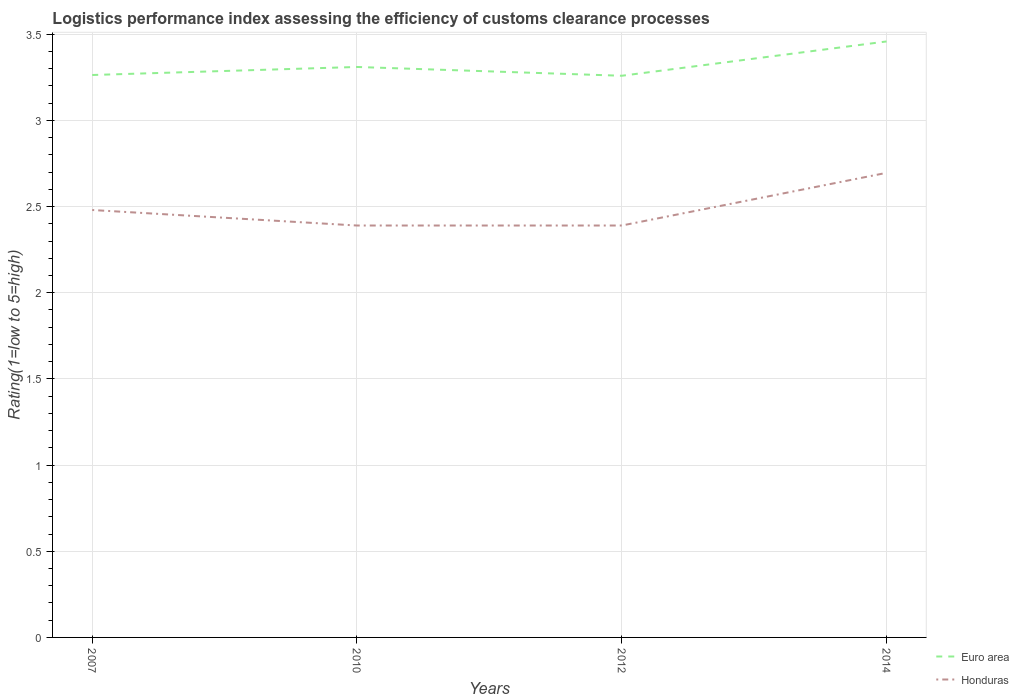Does the line corresponding to Euro area intersect with the line corresponding to Honduras?
Offer a terse response. No. Across all years, what is the maximum Logistic performance index in Honduras?
Make the answer very short. 2.39. In which year was the Logistic performance index in Honduras maximum?
Provide a succinct answer. 2010. What is the total Logistic performance index in Honduras in the graph?
Offer a very short reply. -0.31. What is the difference between the highest and the second highest Logistic performance index in Honduras?
Your response must be concise. 0.31. What is the difference between the highest and the lowest Logistic performance index in Honduras?
Offer a very short reply. 1. Is the Logistic performance index in Euro area strictly greater than the Logistic performance index in Honduras over the years?
Provide a succinct answer. No. How many lines are there?
Ensure brevity in your answer.  2. Does the graph contain any zero values?
Offer a terse response. No. How many legend labels are there?
Make the answer very short. 2. How are the legend labels stacked?
Your response must be concise. Vertical. What is the title of the graph?
Ensure brevity in your answer.  Logistics performance index assessing the efficiency of customs clearance processes. Does "Bahrain" appear as one of the legend labels in the graph?
Provide a succinct answer. No. What is the label or title of the Y-axis?
Offer a very short reply. Rating(1=low to 5=high). What is the Rating(1=low to 5=high) of Euro area in 2007?
Your answer should be compact. 3.26. What is the Rating(1=low to 5=high) in Honduras in 2007?
Your answer should be very brief. 2.48. What is the Rating(1=low to 5=high) of Euro area in 2010?
Offer a terse response. 3.31. What is the Rating(1=low to 5=high) in Honduras in 2010?
Ensure brevity in your answer.  2.39. What is the Rating(1=low to 5=high) in Euro area in 2012?
Provide a succinct answer. 3.26. What is the Rating(1=low to 5=high) of Honduras in 2012?
Offer a very short reply. 2.39. What is the Rating(1=low to 5=high) in Euro area in 2014?
Your answer should be compact. 3.46. What is the Rating(1=low to 5=high) in Honduras in 2014?
Your answer should be very brief. 2.7. Across all years, what is the maximum Rating(1=low to 5=high) of Euro area?
Provide a short and direct response. 3.46. Across all years, what is the maximum Rating(1=low to 5=high) in Honduras?
Make the answer very short. 2.7. Across all years, what is the minimum Rating(1=low to 5=high) in Euro area?
Provide a short and direct response. 3.26. Across all years, what is the minimum Rating(1=low to 5=high) of Honduras?
Keep it short and to the point. 2.39. What is the total Rating(1=low to 5=high) of Euro area in the graph?
Offer a terse response. 13.29. What is the total Rating(1=low to 5=high) in Honduras in the graph?
Keep it short and to the point. 9.96. What is the difference between the Rating(1=low to 5=high) in Euro area in 2007 and that in 2010?
Give a very brief answer. -0.05. What is the difference between the Rating(1=low to 5=high) of Honduras in 2007 and that in 2010?
Make the answer very short. 0.09. What is the difference between the Rating(1=low to 5=high) of Euro area in 2007 and that in 2012?
Your answer should be compact. 0. What is the difference between the Rating(1=low to 5=high) of Honduras in 2007 and that in 2012?
Your response must be concise. 0.09. What is the difference between the Rating(1=low to 5=high) of Euro area in 2007 and that in 2014?
Offer a very short reply. -0.19. What is the difference between the Rating(1=low to 5=high) in Honduras in 2007 and that in 2014?
Offer a terse response. -0.22. What is the difference between the Rating(1=low to 5=high) in Euro area in 2010 and that in 2012?
Give a very brief answer. 0.05. What is the difference between the Rating(1=low to 5=high) of Euro area in 2010 and that in 2014?
Offer a terse response. -0.15. What is the difference between the Rating(1=low to 5=high) in Honduras in 2010 and that in 2014?
Offer a terse response. -0.31. What is the difference between the Rating(1=low to 5=high) in Euro area in 2012 and that in 2014?
Provide a succinct answer. -0.2. What is the difference between the Rating(1=low to 5=high) in Honduras in 2012 and that in 2014?
Keep it short and to the point. -0.31. What is the difference between the Rating(1=low to 5=high) of Euro area in 2007 and the Rating(1=low to 5=high) of Honduras in 2010?
Ensure brevity in your answer.  0.87. What is the difference between the Rating(1=low to 5=high) of Euro area in 2007 and the Rating(1=low to 5=high) of Honduras in 2012?
Provide a short and direct response. 0.87. What is the difference between the Rating(1=low to 5=high) of Euro area in 2007 and the Rating(1=low to 5=high) of Honduras in 2014?
Offer a terse response. 0.57. What is the difference between the Rating(1=low to 5=high) of Euro area in 2010 and the Rating(1=low to 5=high) of Honduras in 2012?
Offer a very short reply. 0.92. What is the difference between the Rating(1=low to 5=high) in Euro area in 2010 and the Rating(1=low to 5=high) in Honduras in 2014?
Offer a very short reply. 0.61. What is the difference between the Rating(1=low to 5=high) of Euro area in 2012 and the Rating(1=low to 5=high) of Honduras in 2014?
Keep it short and to the point. 0.56. What is the average Rating(1=low to 5=high) of Euro area per year?
Keep it short and to the point. 3.32. What is the average Rating(1=low to 5=high) of Honduras per year?
Your answer should be very brief. 2.49. In the year 2007, what is the difference between the Rating(1=low to 5=high) in Euro area and Rating(1=low to 5=high) in Honduras?
Provide a succinct answer. 0.78. In the year 2010, what is the difference between the Rating(1=low to 5=high) of Euro area and Rating(1=low to 5=high) of Honduras?
Make the answer very short. 0.92. In the year 2012, what is the difference between the Rating(1=low to 5=high) in Euro area and Rating(1=low to 5=high) in Honduras?
Your answer should be very brief. 0.87. In the year 2014, what is the difference between the Rating(1=low to 5=high) in Euro area and Rating(1=low to 5=high) in Honduras?
Offer a terse response. 0.76. What is the ratio of the Rating(1=low to 5=high) in Euro area in 2007 to that in 2010?
Your response must be concise. 0.99. What is the ratio of the Rating(1=low to 5=high) in Honduras in 2007 to that in 2010?
Offer a terse response. 1.04. What is the ratio of the Rating(1=low to 5=high) in Euro area in 2007 to that in 2012?
Provide a succinct answer. 1. What is the ratio of the Rating(1=low to 5=high) in Honduras in 2007 to that in 2012?
Provide a short and direct response. 1.04. What is the ratio of the Rating(1=low to 5=high) in Euro area in 2007 to that in 2014?
Give a very brief answer. 0.94. What is the ratio of the Rating(1=low to 5=high) of Euro area in 2010 to that in 2012?
Make the answer very short. 1.02. What is the ratio of the Rating(1=low to 5=high) in Euro area in 2010 to that in 2014?
Your answer should be compact. 0.96. What is the ratio of the Rating(1=low to 5=high) of Honduras in 2010 to that in 2014?
Give a very brief answer. 0.89. What is the ratio of the Rating(1=low to 5=high) in Euro area in 2012 to that in 2014?
Your answer should be very brief. 0.94. What is the ratio of the Rating(1=low to 5=high) of Honduras in 2012 to that in 2014?
Your response must be concise. 0.89. What is the difference between the highest and the second highest Rating(1=low to 5=high) of Euro area?
Provide a short and direct response. 0.15. What is the difference between the highest and the second highest Rating(1=low to 5=high) of Honduras?
Offer a very short reply. 0.22. What is the difference between the highest and the lowest Rating(1=low to 5=high) in Euro area?
Keep it short and to the point. 0.2. What is the difference between the highest and the lowest Rating(1=low to 5=high) in Honduras?
Offer a very short reply. 0.31. 